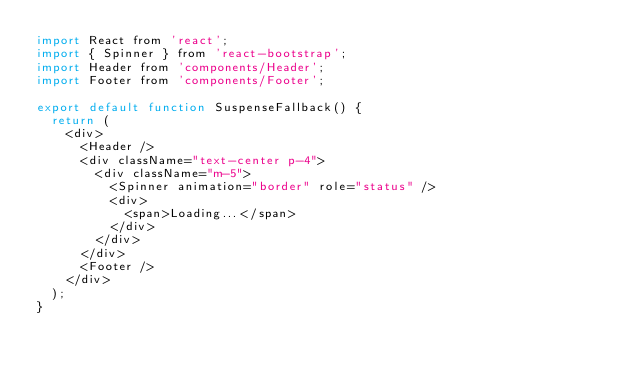Convert code to text. <code><loc_0><loc_0><loc_500><loc_500><_JavaScript_>import React from 'react';
import { Spinner } from 'react-bootstrap';
import Header from 'components/Header';
import Footer from 'components/Footer';

export default function SuspenseFallback() {
  return (
    <div>
      <Header />
      <div className="text-center p-4">
        <div className="m-5">
          <Spinner animation="border" role="status" />
          <div>
            <span>Loading...</span>
          </div>
        </div>
      </div>
      <Footer />
    </div>
  );
}
</code> 